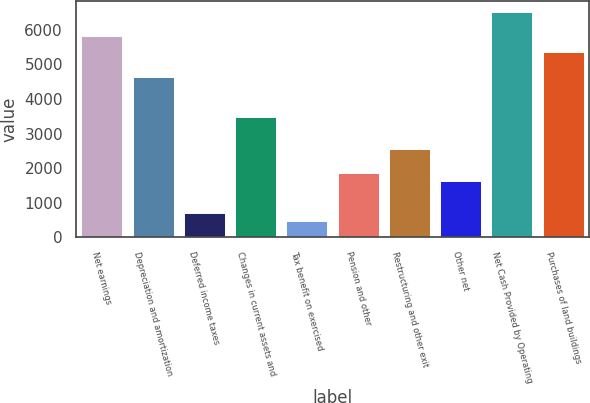<chart> <loc_0><loc_0><loc_500><loc_500><bar_chart><fcel>Net earnings<fcel>Depreciation and amortization<fcel>Deferred income taxes<fcel>Changes in current assets and<fcel>Tax benefit on exercised<fcel>Pension and other<fcel>Restructuring and other exit<fcel>Other net<fcel>Net Cash Provided by Operating<fcel>Purchases of land buildings<nl><fcel>5804<fcel>4646<fcel>708.8<fcel>3488<fcel>477.2<fcel>1866.8<fcel>2561.6<fcel>1635.2<fcel>6498.8<fcel>5340.8<nl></chart> 